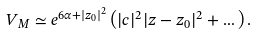<formula> <loc_0><loc_0><loc_500><loc_500>V _ { M } \simeq e ^ { 6 \alpha + | z _ { 0 } | ^ { 2 } } \left ( | c | ^ { 2 } | z - z _ { 0 } | ^ { 2 } + \dots \right ) .</formula> 